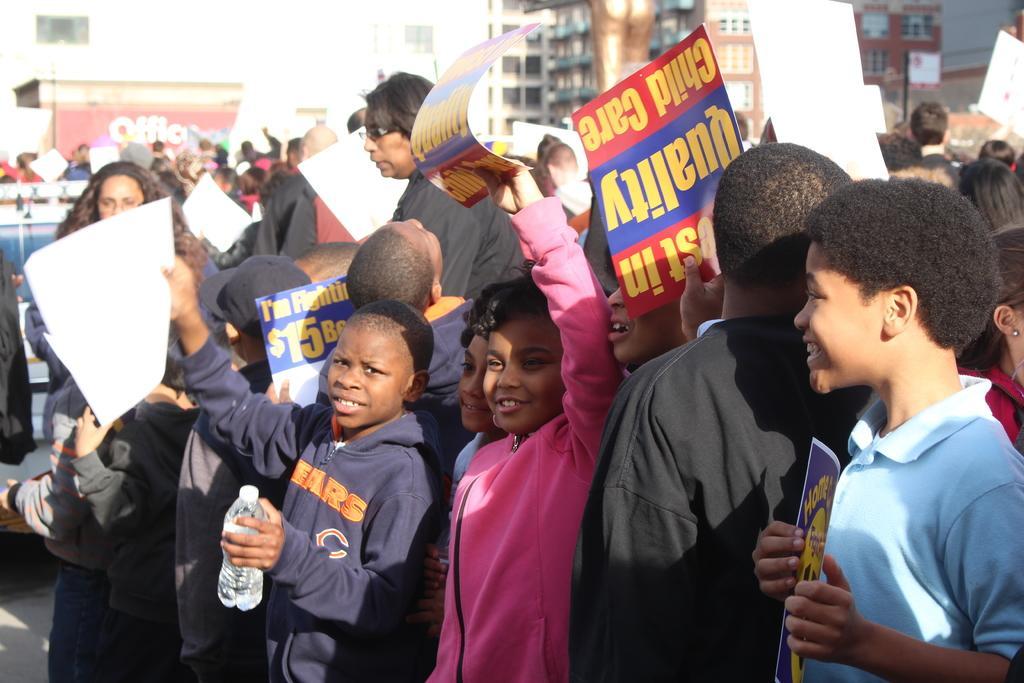Describe this image in one or two sentences. In this image, we can see kids wearing clothes and holding placards. There is a building at the top of the image. 